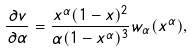<formula> <loc_0><loc_0><loc_500><loc_500>\frac { \partial v } { \partial \alpha } = \frac { x ^ { \alpha } ( 1 - x ) ^ { 2 } } { \alpha ( 1 - x ^ { \alpha } ) ^ { 3 } } w _ { \alpha } ( x ^ { \alpha } ) ,</formula> 